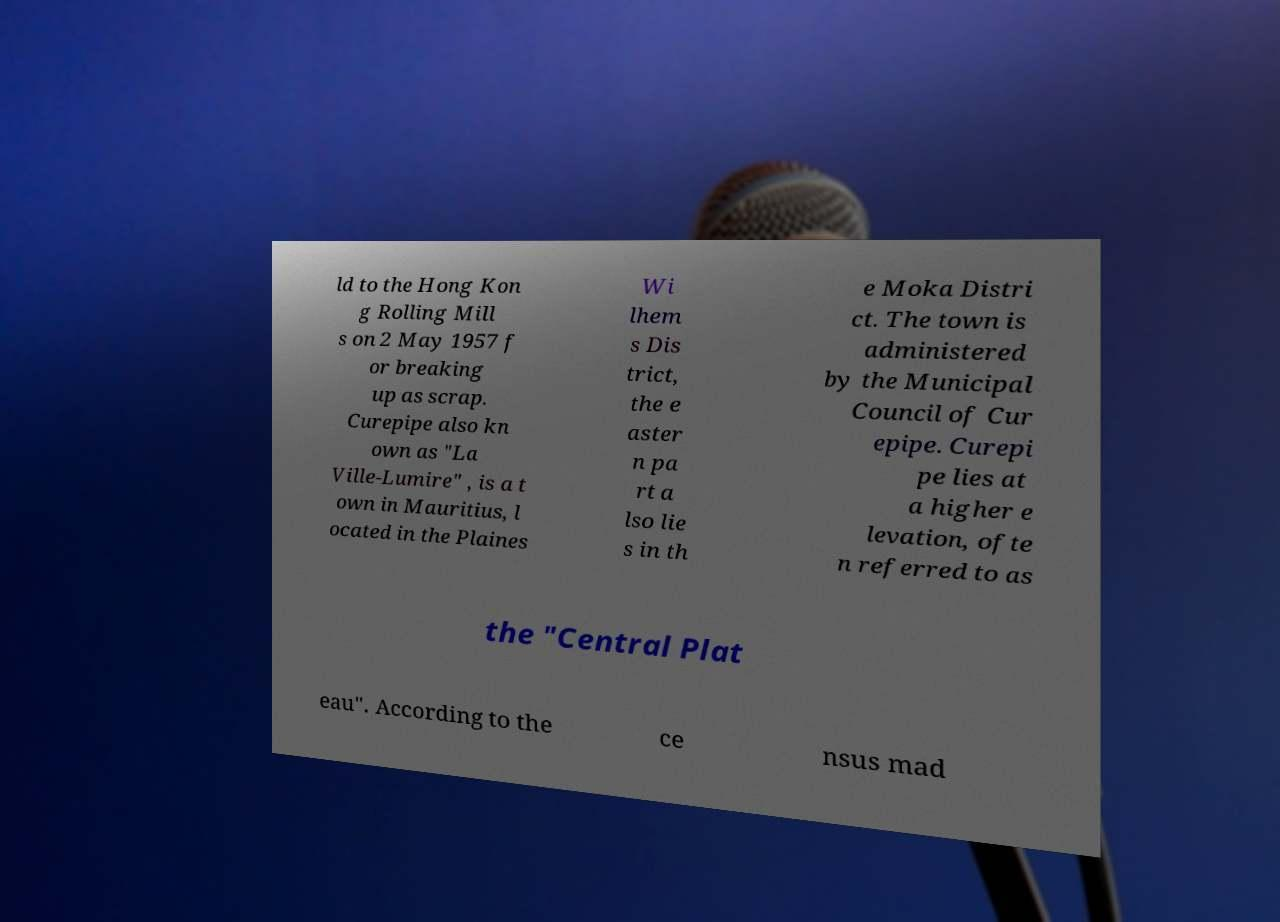Please identify and transcribe the text found in this image. ld to the Hong Kon g Rolling Mill s on 2 May 1957 f or breaking up as scrap. Curepipe also kn own as "La Ville-Lumire" , is a t own in Mauritius, l ocated in the Plaines Wi lhem s Dis trict, the e aster n pa rt a lso lie s in th e Moka Distri ct. The town is administered by the Municipal Council of Cur epipe. Curepi pe lies at a higher e levation, ofte n referred to as the "Central Plat eau". According to the ce nsus mad 